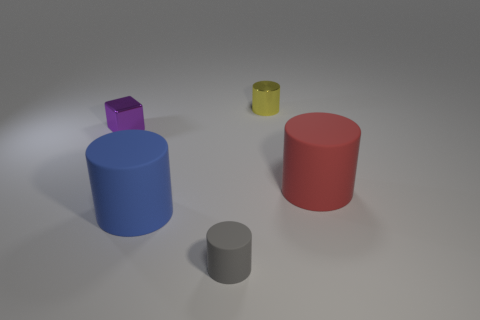Is the red matte cylinder the same size as the yellow metallic thing?
Provide a short and direct response. No. What material is the yellow object?
Give a very brief answer. Metal. Does the big rubber object on the left side of the big red cylinder have the same shape as the purple metallic thing?
Offer a terse response. No. How many objects are rubber things or small gray cylinders?
Offer a terse response. 3. Is the material of the tiny cylinder in front of the purple thing the same as the large red cylinder?
Your answer should be compact. Yes. How big is the red cylinder?
Your response must be concise. Large. What number of cylinders are either red rubber objects or small yellow metal things?
Give a very brief answer. 2. Is the number of cylinders that are in front of the small shiny cylinder the same as the number of shiny objects that are on the left side of the small gray cylinder?
Provide a short and direct response. No. What is the size of the blue matte thing that is the same shape as the big red matte object?
Keep it short and to the point. Large. What is the size of the thing that is behind the big red thing and in front of the small yellow metallic object?
Offer a terse response. Small. 